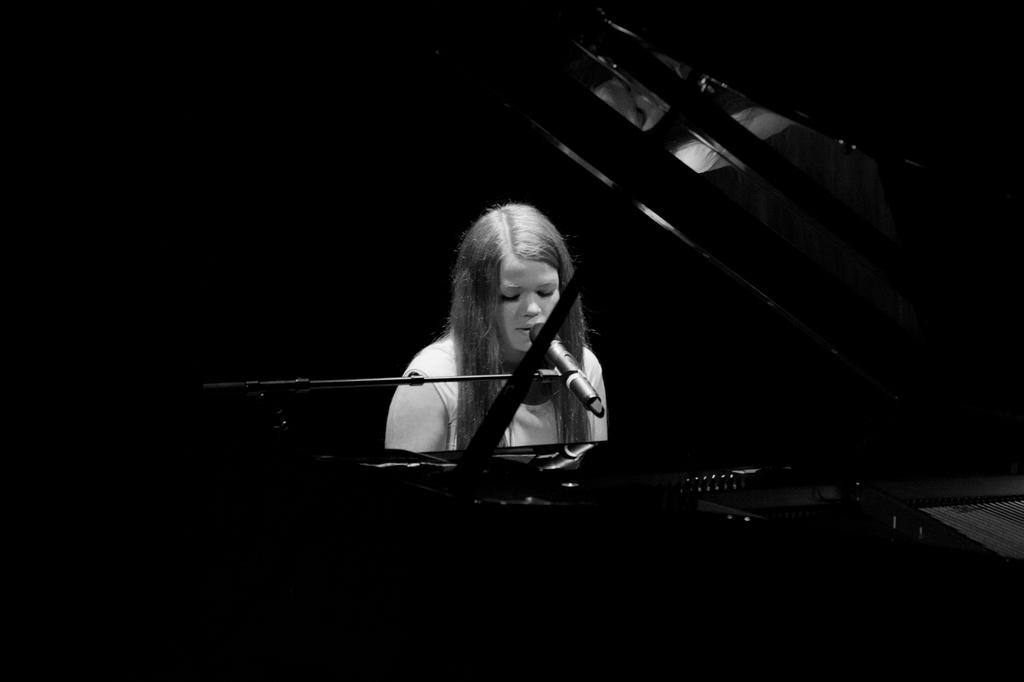What is the woman in the image doing? The woman is sitting in the image. What is in front of the woman? There are microphones with stands in front of the woman. Can you describe the unspecified object in the image? Unfortunately, there is not enough information provided to describe the unspecified object in the image. What type of linen is draped over the microphone stands in the image? There is no linen draped over the microphone stands in the image. How does the woman look in the image? The provided facts do not include any information about the woman's appearance, so we cannot answer this question. 